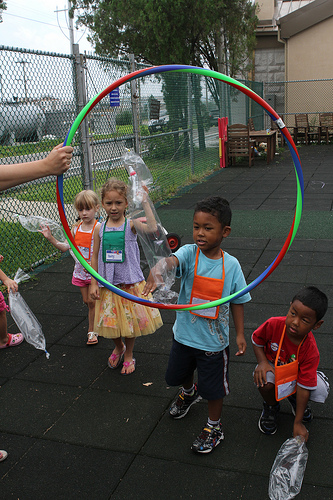<image>
Is the child on the toy? No. The child is not positioned on the toy. They may be near each other, but the child is not supported by or resting on top of the toy. 